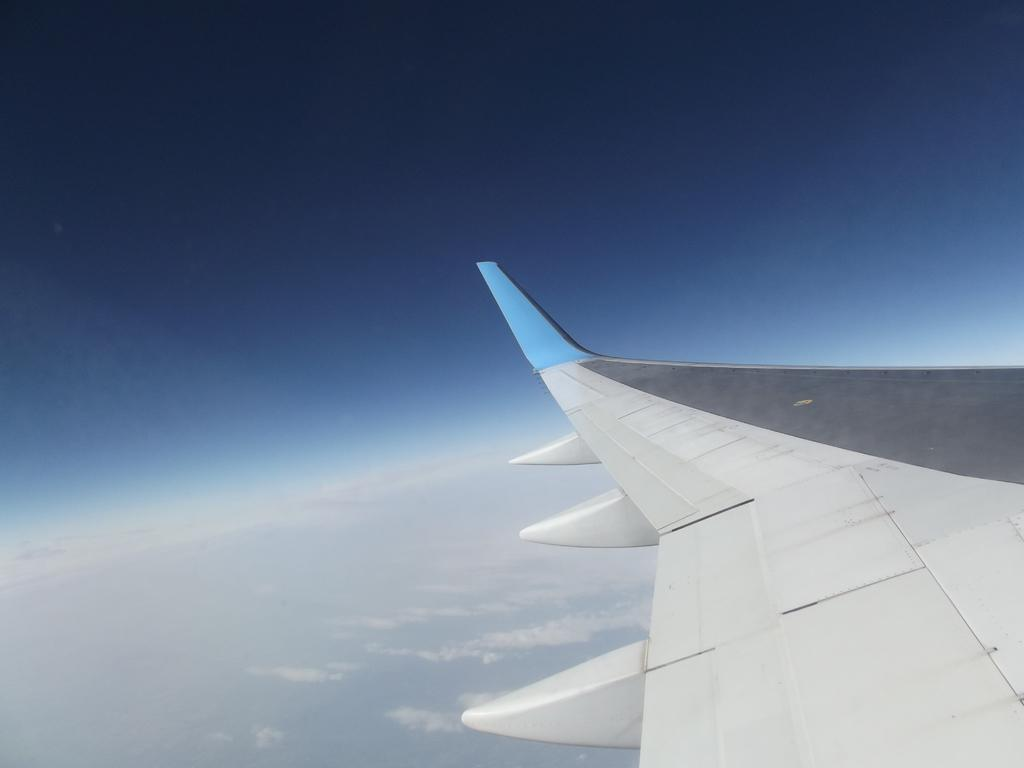What is visible in the sky in the image? There is an aircraft wing in the sky. Can you describe the sky's appearance in the image? The sky is blue with clouds. Where is the fireman standing in the image? There is no fireman present in the image. What type of rail can be seen connecting the clouds in the image? There is no rail connecting the clouds in the image. 